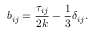Convert formula to latex. <formula><loc_0><loc_0><loc_500><loc_500>b _ { i j } = \frac { \tau _ { i j } } { 2 k } - \frac { 1 } { 3 } \delta _ { i j } .</formula> 